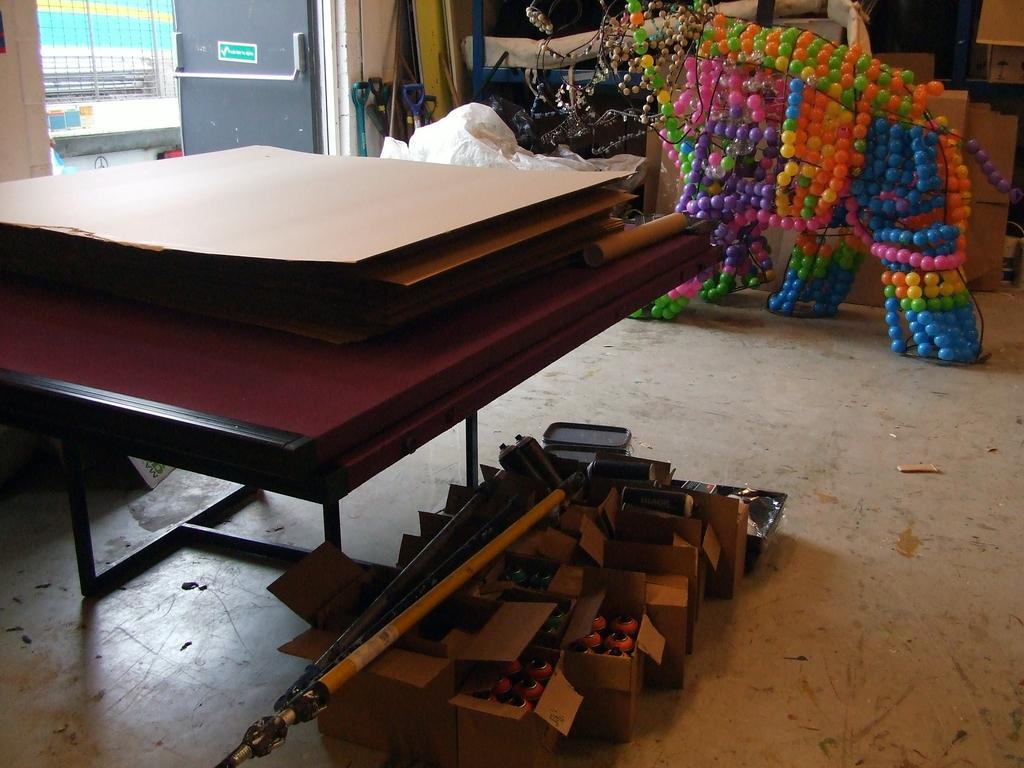Please provide a concise description of this image. In this image, we can see some cardboards on the table and in the background, we can see a wall, mesh, door, some objects, a cloth which is in white color and we can see some decor lights and there are some boxes and sticks. At the bottom, we can see boxes which are filled with bulbs and some objects and there are sticks on them and there is floor. 